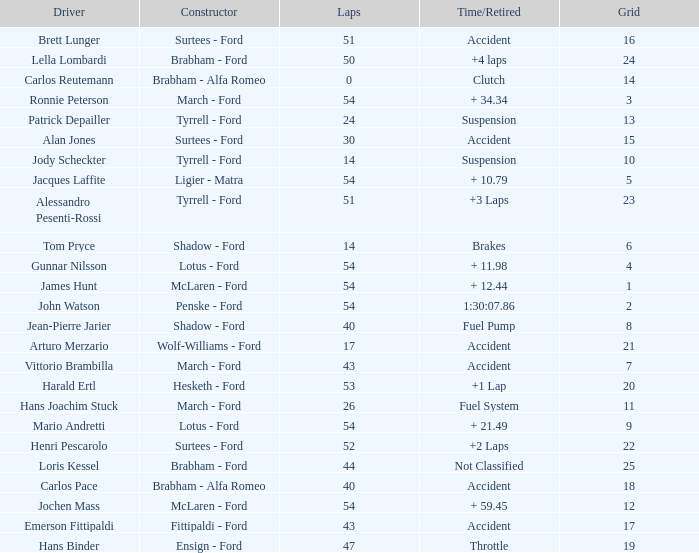How many laps did Emerson Fittipaldi do on a grid larger than 14, and when was the Time/Retired of accident? 1.0. 